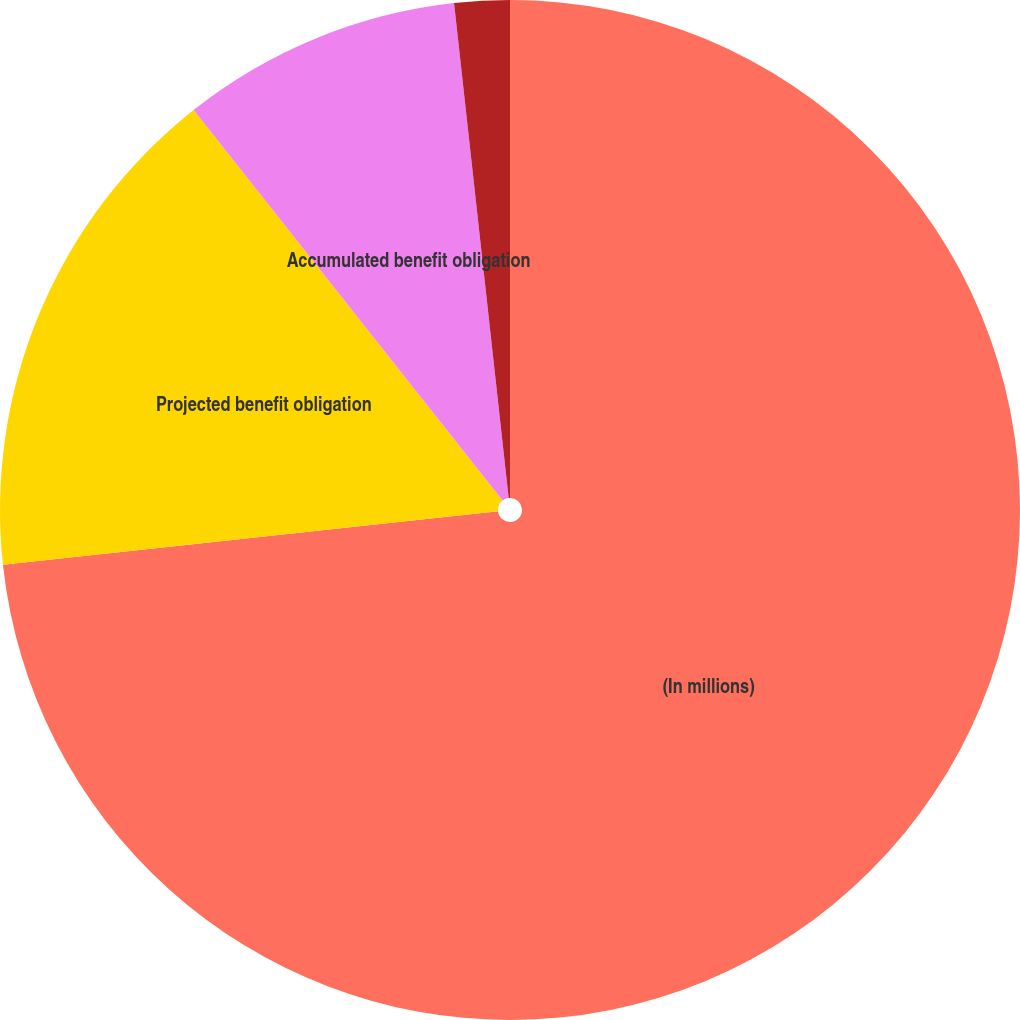<chart> <loc_0><loc_0><loc_500><loc_500><pie_chart><fcel>(In millions)<fcel>Projected benefit obligation<fcel>Accumulated benefit obligation<fcel>Fair value of plan assets<nl><fcel>73.29%<fcel>16.06%<fcel>8.9%<fcel>1.75%<nl></chart> 